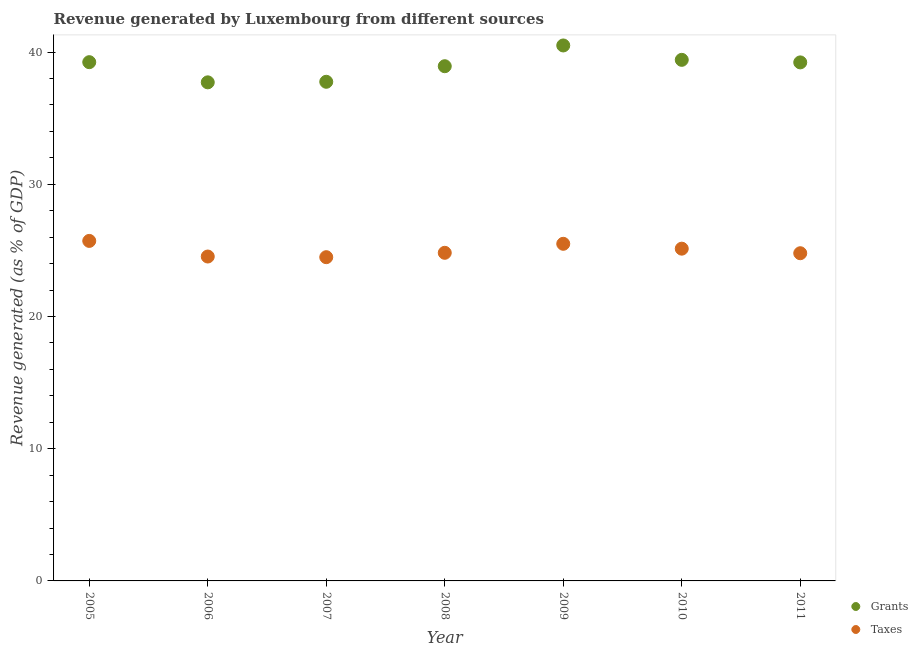What is the revenue generated by grants in 2005?
Provide a succinct answer. 39.23. Across all years, what is the maximum revenue generated by taxes?
Your answer should be compact. 25.71. Across all years, what is the minimum revenue generated by grants?
Your response must be concise. 37.71. What is the total revenue generated by grants in the graph?
Offer a terse response. 272.73. What is the difference between the revenue generated by grants in 2005 and that in 2011?
Provide a succinct answer. 0.02. What is the difference between the revenue generated by taxes in 2006 and the revenue generated by grants in 2008?
Keep it short and to the point. -14.39. What is the average revenue generated by grants per year?
Keep it short and to the point. 38.96. In the year 2007, what is the difference between the revenue generated by grants and revenue generated by taxes?
Your answer should be compact. 13.26. What is the ratio of the revenue generated by taxes in 2007 to that in 2010?
Provide a short and direct response. 0.97. Is the difference between the revenue generated by grants in 2007 and 2009 greater than the difference between the revenue generated by taxes in 2007 and 2009?
Ensure brevity in your answer.  No. What is the difference between the highest and the second highest revenue generated by grants?
Keep it short and to the point. 1.09. What is the difference between the highest and the lowest revenue generated by taxes?
Give a very brief answer. 1.23. In how many years, is the revenue generated by grants greater than the average revenue generated by grants taken over all years?
Give a very brief answer. 4. Is the sum of the revenue generated by taxes in 2005 and 2010 greater than the maximum revenue generated by grants across all years?
Give a very brief answer. Yes. Does the graph contain any zero values?
Provide a short and direct response. No. Where does the legend appear in the graph?
Offer a terse response. Bottom right. How are the legend labels stacked?
Ensure brevity in your answer.  Vertical. What is the title of the graph?
Ensure brevity in your answer.  Revenue generated by Luxembourg from different sources. Does "Crop" appear as one of the legend labels in the graph?
Give a very brief answer. No. What is the label or title of the X-axis?
Offer a terse response. Year. What is the label or title of the Y-axis?
Your answer should be compact. Revenue generated (as % of GDP). What is the Revenue generated (as % of GDP) of Grants in 2005?
Provide a short and direct response. 39.23. What is the Revenue generated (as % of GDP) in Taxes in 2005?
Your response must be concise. 25.71. What is the Revenue generated (as % of GDP) of Grants in 2006?
Offer a very short reply. 37.71. What is the Revenue generated (as % of GDP) in Taxes in 2006?
Keep it short and to the point. 24.53. What is the Revenue generated (as % of GDP) in Grants in 2007?
Ensure brevity in your answer.  37.75. What is the Revenue generated (as % of GDP) in Taxes in 2007?
Offer a very short reply. 24.48. What is the Revenue generated (as % of GDP) of Grants in 2008?
Your answer should be compact. 38.93. What is the Revenue generated (as % of GDP) in Taxes in 2008?
Your response must be concise. 24.81. What is the Revenue generated (as % of GDP) in Grants in 2009?
Your answer should be compact. 40.5. What is the Revenue generated (as % of GDP) of Taxes in 2009?
Keep it short and to the point. 25.5. What is the Revenue generated (as % of GDP) in Grants in 2010?
Your answer should be compact. 39.41. What is the Revenue generated (as % of GDP) in Taxes in 2010?
Provide a succinct answer. 25.13. What is the Revenue generated (as % of GDP) of Grants in 2011?
Provide a succinct answer. 39.22. What is the Revenue generated (as % of GDP) of Taxes in 2011?
Your response must be concise. 24.78. Across all years, what is the maximum Revenue generated (as % of GDP) of Grants?
Offer a terse response. 40.5. Across all years, what is the maximum Revenue generated (as % of GDP) of Taxes?
Give a very brief answer. 25.71. Across all years, what is the minimum Revenue generated (as % of GDP) in Grants?
Your response must be concise. 37.71. Across all years, what is the minimum Revenue generated (as % of GDP) of Taxes?
Keep it short and to the point. 24.48. What is the total Revenue generated (as % of GDP) of Grants in the graph?
Offer a terse response. 272.73. What is the total Revenue generated (as % of GDP) in Taxes in the graph?
Make the answer very short. 174.95. What is the difference between the Revenue generated (as % of GDP) in Grants in 2005 and that in 2006?
Make the answer very short. 1.53. What is the difference between the Revenue generated (as % of GDP) of Taxes in 2005 and that in 2006?
Your answer should be compact. 1.18. What is the difference between the Revenue generated (as % of GDP) in Grants in 2005 and that in 2007?
Provide a succinct answer. 1.48. What is the difference between the Revenue generated (as % of GDP) in Taxes in 2005 and that in 2007?
Make the answer very short. 1.23. What is the difference between the Revenue generated (as % of GDP) of Grants in 2005 and that in 2008?
Your answer should be compact. 0.31. What is the difference between the Revenue generated (as % of GDP) of Taxes in 2005 and that in 2008?
Offer a terse response. 0.9. What is the difference between the Revenue generated (as % of GDP) of Grants in 2005 and that in 2009?
Your answer should be very brief. -1.26. What is the difference between the Revenue generated (as % of GDP) in Taxes in 2005 and that in 2009?
Your answer should be very brief. 0.22. What is the difference between the Revenue generated (as % of GDP) in Grants in 2005 and that in 2010?
Offer a very short reply. -0.18. What is the difference between the Revenue generated (as % of GDP) in Taxes in 2005 and that in 2010?
Make the answer very short. 0.59. What is the difference between the Revenue generated (as % of GDP) of Grants in 2005 and that in 2011?
Your answer should be compact. 0.02. What is the difference between the Revenue generated (as % of GDP) of Taxes in 2005 and that in 2011?
Offer a terse response. 0.93. What is the difference between the Revenue generated (as % of GDP) in Grants in 2006 and that in 2007?
Ensure brevity in your answer.  -0.04. What is the difference between the Revenue generated (as % of GDP) of Taxes in 2006 and that in 2007?
Ensure brevity in your answer.  0.05. What is the difference between the Revenue generated (as % of GDP) of Grants in 2006 and that in 2008?
Your answer should be very brief. -1.22. What is the difference between the Revenue generated (as % of GDP) of Taxes in 2006 and that in 2008?
Offer a very short reply. -0.28. What is the difference between the Revenue generated (as % of GDP) in Grants in 2006 and that in 2009?
Give a very brief answer. -2.79. What is the difference between the Revenue generated (as % of GDP) of Taxes in 2006 and that in 2009?
Your answer should be compact. -0.96. What is the difference between the Revenue generated (as % of GDP) in Grants in 2006 and that in 2010?
Offer a very short reply. -1.7. What is the difference between the Revenue generated (as % of GDP) of Taxes in 2006 and that in 2010?
Make the answer very short. -0.59. What is the difference between the Revenue generated (as % of GDP) in Grants in 2006 and that in 2011?
Keep it short and to the point. -1.51. What is the difference between the Revenue generated (as % of GDP) in Taxes in 2006 and that in 2011?
Your answer should be very brief. -0.25. What is the difference between the Revenue generated (as % of GDP) in Grants in 2007 and that in 2008?
Provide a succinct answer. -1.18. What is the difference between the Revenue generated (as % of GDP) in Taxes in 2007 and that in 2008?
Your response must be concise. -0.33. What is the difference between the Revenue generated (as % of GDP) in Grants in 2007 and that in 2009?
Keep it short and to the point. -2.75. What is the difference between the Revenue generated (as % of GDP) in Taxes in 2007 and that in 2009?
Ensure brevity in your answer.  -1.01. What is the difference between the Revenue generated (as % of GDP) of Grants in 2007 and that in 2010?
Provide a short and direct response. -1.66. What is the difference between the Revenue generated (as % of GDP) in Taxes in 2007 and that in 2010?
Provide a succinct answer. -0.64. What is the difference between the Revenue generated (as % of GDP) of Grants in 2007 and that in 2011?
Offer a very short reply. -1.47. What is the difference between the Revenue generated (as % of GDP) of Taxes in 2007 and that in 2011?
Give a very brief answer. -0.3. What is the difference between the Revenue generated (as % of GDP) in Grants in 2008 and that in 2009?
Your answer should be very brief. -1.57. What is the difference between the Revenue generated (as % of GDP) of Taxes in 2008 and that in 2009?
Your response must be concise. -0.68. What is the difference between the Revenue generated (as % of GDP) of Grants in 2008 and that in 2010?
Your answer should be compact. -0.48. What is the difference between the Revenue generated (as % of GDP) in Taxes in 2008 and that in 2010?
Keep it short and to the point. -0.31. What is the difference between the Revenue generated (as % of GDP) of Grants in 2008 and that in 2011?
Ensure brevity in your answer.  -0.29. What is the difference between the Revenue generated (as % of GDP) of Taxes in 2008 and that in 2011?
Offer a very short reply. 0.03. What is the difference between the Revenue generated (as % of GDP) of Grants in 2009 and that in 2010?
Your answer should be compact. 1.09. What is the difference between the Revenue generated (as % of GDP) in Taxes in 2009 and that in 2010?
Ensure brevity in your answer.  0.37. What is the difference between the Revenue generated (as % of GDP) of Grants in 2009 and that in 2011?
Provide a succinct answer. 1.28. What is the difference between the Revenue generated (as % of GDP) in Taxes in 2009 and that in 2011?
Provide a short and direct response. 0.71. What is the difference between the Revenue generated (as % of GDP) of Grants in 2010 and that in 2011?
Provide a short and direct response. 0.19. What is the difference between the Revenue generated (as % of GDP) of Taxes in 2010 and that in 2011?
Make the answer very short. 0.34. What is the difference between the Revenue generated (as % of GDP) in Grants in 2005 and the Revenue generated (as % of GDP) in Taxes in 2006?
Make the answer very short. 14.7. What is the difference between the Revenue generated (as % of GDP) of Grants in 2005 and the Revenue generated (as % of GDP) of Taxes in 2007?
Your answer should be compact. 14.75. What is the difference between the Revenue generated (as % of GDP) of Grants in 2005 and the Revenue generated (as % of GDP) of Taxes in 2008?
Offer a very short reply. 14.42. What is the difference between the Revenue generated (as % of GDP) of Grants in 2005 and the Revenue generated (as % of GDP) of Taxes in 2009?
Make the answer very short. 13.74. What is the difference between the Revenue generated (as % of GDP) of Grants in 2005 and the Revenue generated (as % of GDP) of Taxes in 2010?
Your answer should be compact. 14.1. What is the difference between the Revenue generated (as % of GDP) of Grants in 2005 and the Revenue generated (as % of GDP) of Taxes in 2011?
Keep it short and to the point. 14.45. What is the difference between the Revenue generated (as % of GDP) of Grants in 2006 and the Revenue generated (as % of GDP) of Taxes in 2007?
Keep it short and to the point. 13.22. What is the difference between the Revenue generated (as % of GDP) in Grants in 2006 and the Revenue generated (as % of GDP) in Taxes in 2008?
Provide a short and direct response. 12.89. What is the difference between the Revenue generated (as % of GDP) of Grants in 2006 and the Revenue generated (as % of GDP) of Taxes in 2009?
Provide a succinct answer. 12.21. What is the difference between the Revenue generated (as % of GDP) of Grants in 2006 and the Revenue generated (as % of GDP) of Taxes in 2010?
Your answer should be compact. 12.58. What is the difference between the Revenue generated (as % of GDP) of Grants in 2006 and the Revenue generated (as % of GDP) of Taxes in 2011?
Give a very brief answer. 12.92. What is the difference between the Revenue generated (as % of GDP) of Grants in 2007 and the Revenue generated (as % of GDP) of Taxes in 2008?
Offer a terse response. 12.93. What is the difference between the Revenue generated (as % of GDP) in Grants in 2007 and the Revenue generated (as % of GDP) in Taxes in 2009?
Provide a short and direct response. 12.25. What is the difference between the Revenue generated (as % of GDP) of Grants in 2007 and the Revenue generated (as % of GDP) of Taxes in 2010?
Your answer should be very brief. 12.62. What is the difference between the Revenue generated (as % of GDP) in Grants in 2007 and the Revenue generated (as % of GDP) in Taxes in 2011?
Provide a short and direct response. 12.97. What is the difference between the Revenue generated (as % of GDP) in Grants in 2008 and the Revenue generated (as % of GDP) in Taxes in 2009?
Provide a succinct answer. 13.43. What is the difference between the Revenue generated (as % of GDP) of Grants in 2008 and the Revenue generated (as % of GDP) of Taxes in 2010?
Provide a succinct answer. 13.8. What is the difference between the Revenue generated (as % of GDP) in Grants in 2008 and the Revenue generated (as % of GDP) in Taxes in 2011?
Offer a very short reply. 14.14. What is the difference between the Revenue generated (as % of GDP) in Grants in 2009 and the Revenue generated (as % of GDP) in Taxes in 2010?
Keep it short and to the point. 15.37. What is the difference between the Revenue generated (as % of GDP) in Grants in 2009 and the Revenue generated (as % of GDP) in Taxes in 2011?
Ensure brevity in your answer.  15.71. What is the difference between the Revenue generated (as % of GDP) of Grants in 2010 and the Revenue generated (as % of GDP) of Taxes in 2011?
Offer a terse response. 14.63. What is the average Revenue generated (as % of GDP) of Grants per year?
Ensure brevity in your answer.  38.96. What is the average Revenue generated (as % of GDP) in Taxes per year?
Provide a short and direct response. 24.99. In the year 2005, what is the difference between the Revenue generated (as % of GDP) of Grants and Revenue generated (as % of GDP) of Taxes?
Provide a succinct answer. 13.52. In the year 2006, what is the difference between the Revenue generated (as % of GDP) in Grants and Revenue generated (as % of GDP) in Taxes?
Provide a short and direct response. 13.17. In the year 2007, what is the difference between the Revenue generated (as % of GDP) of Grants and Revenue generated (as % of GDP) of Taxes?
Provide a succinct answer. 13.26. In the year 2008, what is the difference between the Revenue generated (as % of GDP) in Grants and Revenue generated (as % of GDP) in Taxes?
Keep it short and to the point. 14.11. In the year 2009, what is the difference between the Revenue generated (as % of GDP) in Grants and Revenue generated (as % of GDP) in Taxes?
Give a very brief answer. 15. In the year 2010, what is the difference between the Revenue generated (as % of GDP) in Grants and Revenue generated (as % of GDP) in Taxes?
Your answer should be compact. 14.28. In the year 2011, what is the difference between the Revenue generated (as % of GDP) in Grants and Revenue generated (as % of GDP) in Taxes?
Provide a short and direct response. 14.43. What is the ratio of the Revenue generated (as % of GDP) in Grants in 2005 to that in 2006?
Provide a succinct answer. 1.04. What is the ratio of the Revenue generated (as % of GDP) of Taxes in 2005 to that in 2006?
Provide a short and direct response. 1.05. What is the ratio of the Revenue generated (as % of GDP) of Grants in 2005 to that in 2007?
Your answer should be very brief. 1.04. What is the ratio of the Revenue generated (as % of GDP) of Taxes in 2005 to that in 2007?
Make the answer very short. 1.05. What is the ratio of the Revenue generated (as % of GDP) in Grants in 2005 to that in 2008?
Offer a very short reply. 1.01. What is the ratio of the Revenue generated (as % of GDP) of Taxes in 2005 to that in 2008?
Make the answer very short. 1.04. What is the ratio of the Revenue generated (as % of GDP) of Grants in 2005 to that in 2009?
Your answer should be compact. 0.97. What is the ratio of the Revenue generated (as % of GDP) of Taxes in 2005 to that in 2009?
Ensure brevity in your answer.  1.01. What is the ratio of the Revenue generated (as % of GDP) in Grants in 2005 to that in 2010?
Provide a short and direct response. 1. What is the ratio of the Revenue generated (as % of GDP) of Taxes in 2005 to that in 2010?
Ensure brevity in your answer.  1.02. What is the ratio of the Revenue generated (as % of GDP) of Taxes in 2005 to that in 2011?
Keep it short and to the point. 1.04. What is the ratio of the Revenue generated (as % of GDP) in Grants in 2006 to that in 2007?
Your response must be concise. 1. What is the ratio of the Revenue generated (as % of GDP) of Grants in 2006 to that in 2008?
Provide a succinct answer. 0.97. What is the ratio of the Revenue generated (as % of GDP) in Taxes in 2006 to that in 2008?
Keep it short and to the point. 0.99. What is the ratio of the Revenue generated (as % of GDP) of Grants in 2006 to that in 2009?
Your answer should be very brief. 0.93. What is the ratio of the Revenue generated (as % of GDP) of Taxes in 2006 to that in 2009?
Keep it short and to the point. 0.96. What is the ratio of the Revenue generated (as % of GDP) of Grants in 2006 to that in 2010?
Keep it short and to the point. 0.96. What is the ratio of the Revenue generated (as % of GDP) of Taxes in 2006 to that in 2010?
Your response must be concise. 0.98. What is the ratio of the Revenue generated (as % of GDP) of Grants in 2006 to that in 2011?
Give a very brief answer. 0.96. What is the ratio of the Revenue generated (as % of GDP) in Taxes in 2006 to that in 2011?
Keep it short and to the point. 0.99. What is the ratio of the Revenue generated (as % of GDP) in Grants in 2007 to that in 2008?
Offer a terse response. 0.97. What is the ratio of the Revenue generated (as % of GDP) in Taxes in 2007 to that in 2008?
Provide a short and direct response. 0.99. What is the ratio of the Revenue generated (as % of GDP) in Grants in 2007 to that in 2009?
Offer a very short reply. 0.93. What is the ratio of the Revenue generated (as % of GDP) of Taxes in 2007 to that in 2009?
Your answer should be very brief. 0.96. What is the ratio of the Revenue generated (as % of GDP) in Grants in 2007 to that in 2010?
Ensure brevity in your answer.  0.96. What is the ratio of the Revenue generated (as % of GDP) of Taxes in 2007 to that in 2010?
Your response must be concise. 0.97. What is the ratio of the Revenue generated (as % of GDP) of Grants in 2007 to that in 2011?
Give a very brief answer. 0.96. What is the ratio of the Revenue generated (as % of GDP) of Taxes in 2007 to that in 2011?
Provide a short and direct response. 0.99. What is the ratio of the Revenue generated (as % of GDP) of Grants in 2008 to that in 2009?
Offer a very short reply. 0.96. What is the ratio of the Revenue generated (as % of GDP) of Taxes in 2008 to that in 2009?
Ensure brevity in your answer.  0.97. What is the ratio of the Revenue generated (as % of GDP) in Grants in 2008 to that in 2010?
Your response must be concise. 0.99. What is the ratio of the Revenue generated (as % of GDP) of Taxes in 2008 to that in 2010?
Your answer should be very brief. 0.99. What is the ratio of the Revenue generated (as % of GDP) in Grants in 2009 to that in 2010?
Your response must be concise. 1.03. What is the ratio of the Revenue generated (as % of GDP) in Taxes in 2009 to that in 2010?
Make the answer very short. 1.01. What is the ratio of the Revenue generated (as % of GDP) of Grants in 2009 to that in 2011?
Provide a succinct answer. 1.03. What is the ratio of the Revenue generated (as % of GDP) of Taxes in 2009 to that in 2011?
Provide a succinct answer. 1.03. What is the ratio of the Revenue generated (as % of GDP) in Grants in 2010 to that in 2011?
Keep it short and to the point. 1. What is the ratio of the Revenue generated (as % of GDP) of Taxes in 2010 to that in 2011?
Your answer should be compact. 1.01. What is the difference between the highest and the second highest Revenue generated (as % of GDP) of Grants?
Give a very brief answer. 1.09. What is the difference between the highest and the second highest Revenue generated (as % of GDP) in Taxes?
Ensure brevity in your answer.  0.22. What is the difference between the highest and the lowest Revenue generated (as % of GDP) in Grants?
Offer a very short reply. 2.79. What is the difference between the highest and the lowest Revenue generated (as % of GDP) in Taxes?
Offer a very short reply. 1.23. 